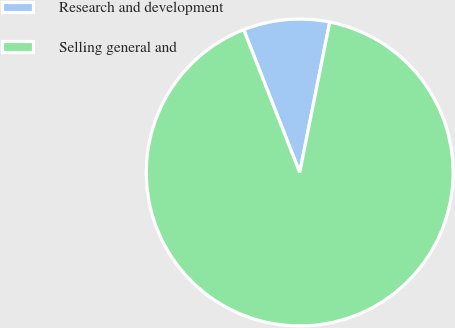Convert chart. <chart><loc_0><loc_0><loc_500><loc_500><pie_chart><fcel>Research and development<fcel>Selling general and<nl><fcel>9.09%<fcel>90.91%<nl></chart> 